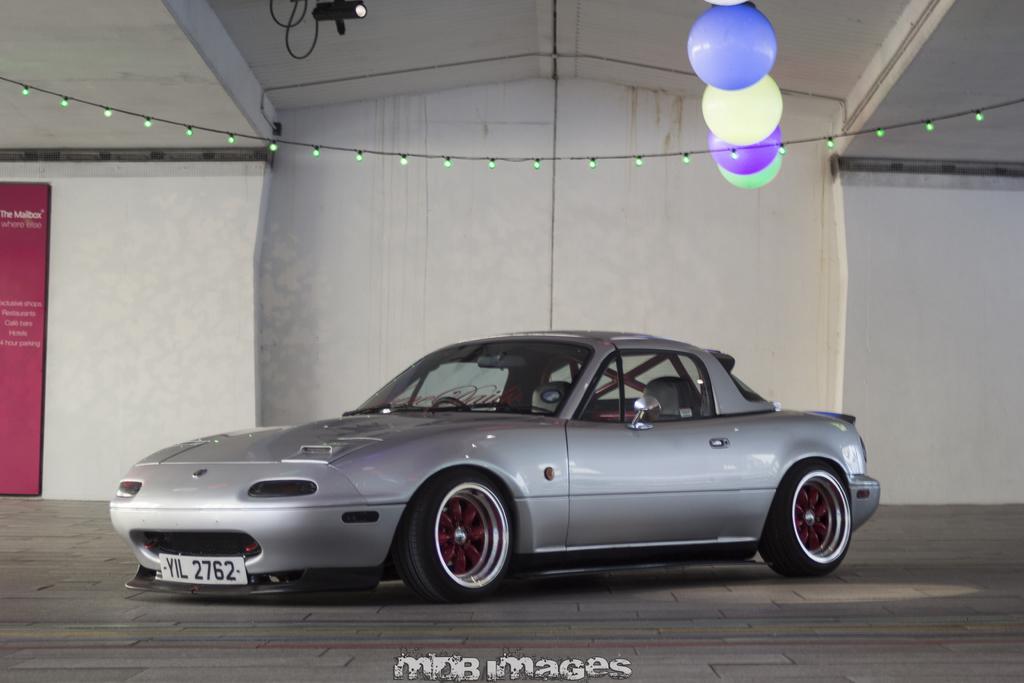Can you describe this image briefly? In this image, we can see a car. We can also see the ground. We can see a wall with a poster on it. We can also see some lights and a few balloons. 